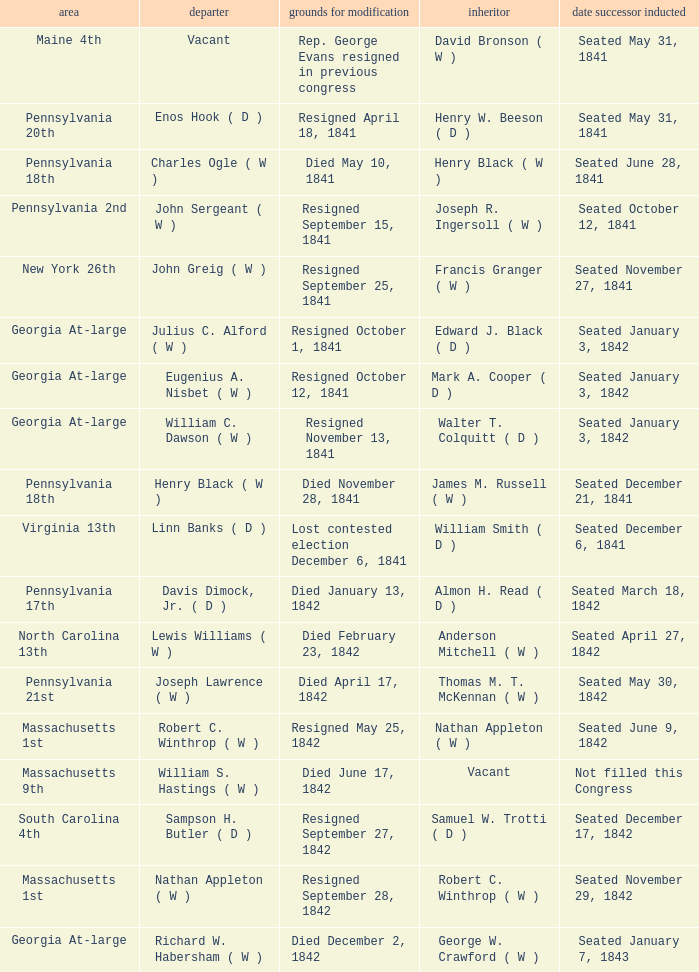What is the date when the successor assumed office in pennsylvania's 17th district? Seated March 18, 1842. 